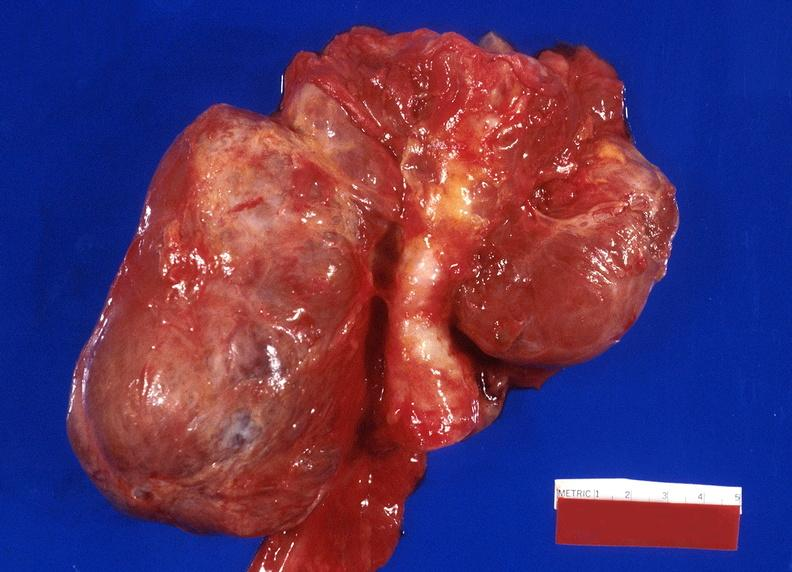where does this belong to?
Answer the question using a single word or phrase. Endocrine system 